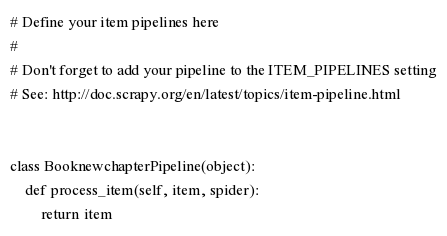<code> <loc_0><loc_0><loc_500><loc_500><_Python_># Define your item pipelines here
#
# Don't forget to add your pipeline to the ITEM_PIPELINES setting
# See: http://doc.scrapy.org/en/latest/topics/item-pipeline.html


class BooknewchapterPipeline(object):
    def process_item(self, item, spider):
        return item
</code> 